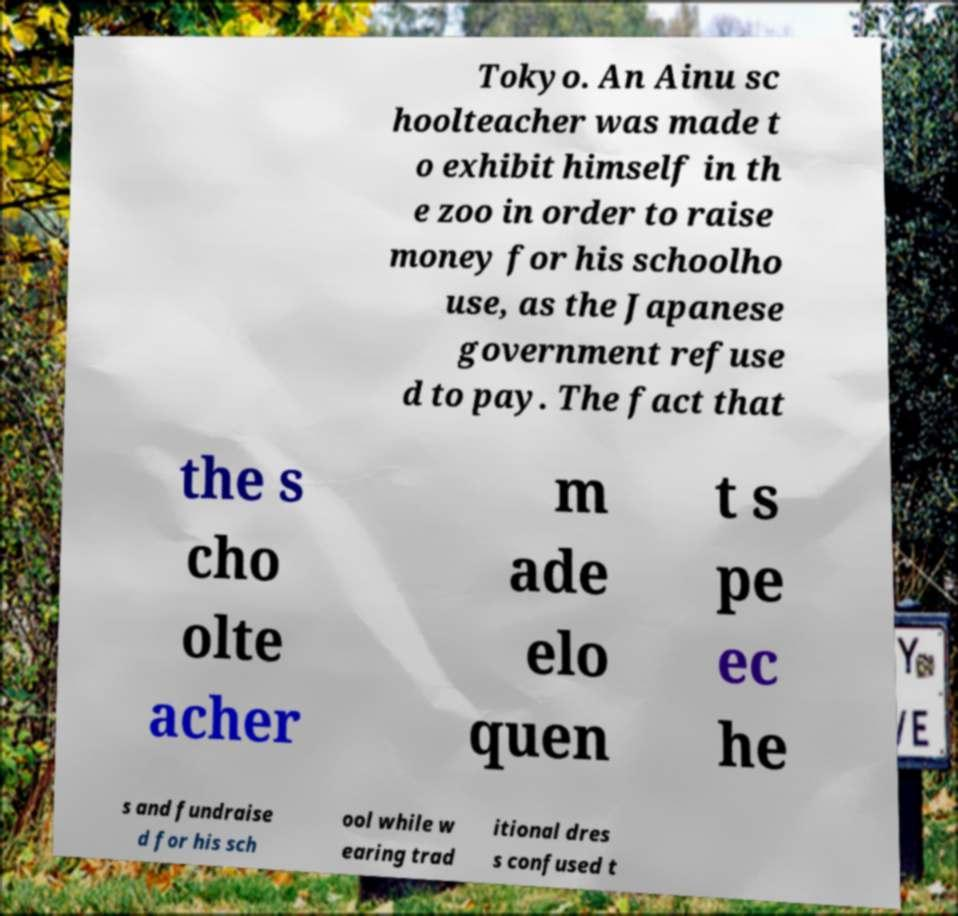Can you accurately transcribe the text from the provided image for me? Tokyo. An Ainu sc hoolteacher was made t o exhibit himself in th e zoo in order to raise money for his schoolho use, as the Japanese government refuse d to pay. The fact that the s cho olte acher m ade elo quen t s pe ec he s and fundraise d for his sch ool while w earing trad itional dres s confused t 